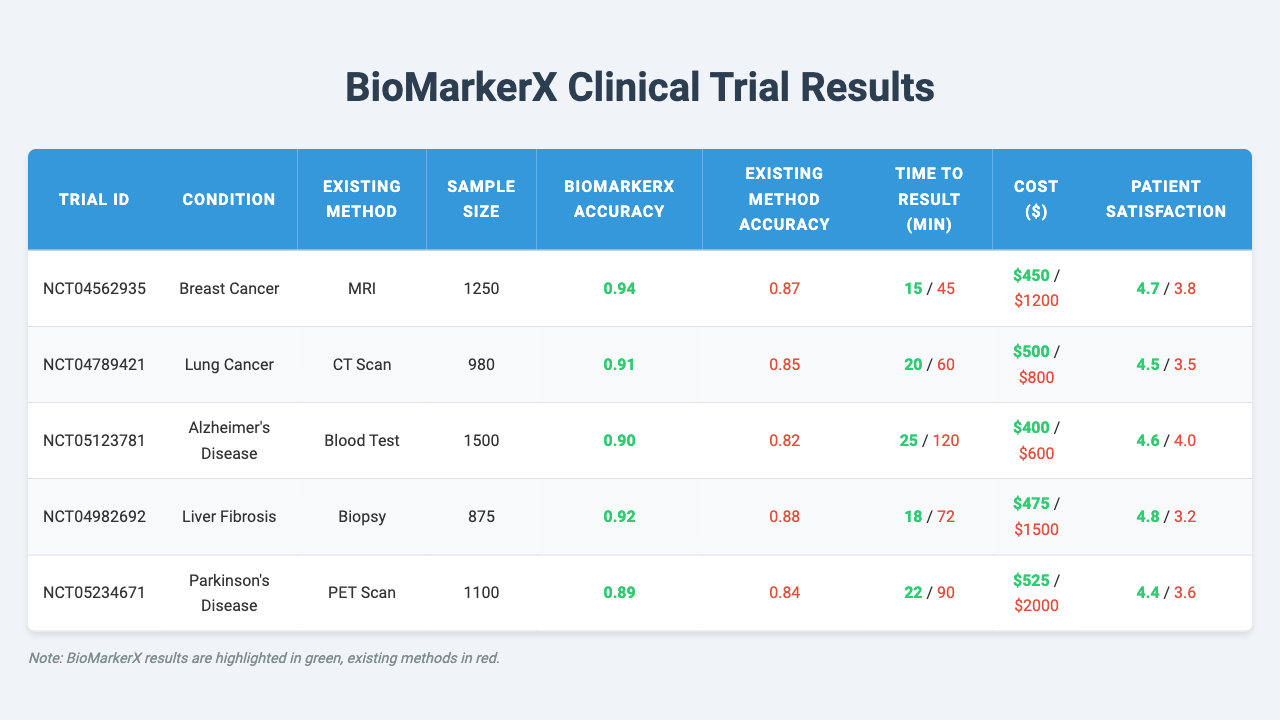What is the highest sensitivity reported for BioMarkerX? From the table, the sensitivity values for BioMarkerX are 0.95, 0.92, 0.89, 0.94, and 0.91. The highest value among these is 0.95.
Answer: 0.95 Which existing method has the highest patient satisfaction rating? The patient satisfaction ratings for existing methods are 3.8, 3.5, 4.0, 3.2, and 3.6. The highest rating is 4.0, corresponding to the Blood Test.
Answer: 4.0 Is the accuracy of BioMarkerX always greater than the accuracy of the existing methods? The accuracy values for BioMarkerX are 0.94, 0.91, 0.90, 0.92, and 0.89, while for existing methods they are 0.87, 0.85, 0.82, 0.88, and 0.84. In each comparison, BioMarkerX shows higher accuracy, so the statement is true.
Answer: Yes What is the average sample size across all trials? The sample sizes for the trials are 1250, 980, 1500, 875, and 1100. Adding these values gives 1250 + 980 + 1500 + 875 + 1100 = 4685. Dividing this sum by 5 results in an average sample size of 4685 / 5 = 937.
Answer: 937 Does BioMarkerX provide results faster than all existing methods listed? Comparing the time to result, BioMarkerX times are 15, 20, 25, 18, and 22 minutes, while the existing methods take 45, 60, 120, 72, and 90 minutes. Since BioMarkerX times are shorter in every case, the answer is true.
Answer: Yes What is the percentage difference in cost between BioMarkerX and the existing methods for Lung Cancer? For Lung Cancer, the cost of BioMarkerX is $500 and the existing method (CT Scan) is $800. To find the percentage difference: (800 - 500) / 800 * 100 = 37.5%.
Answer: 37.5% What is the maximum time to result for the existing methods, and which method does it correspond to? The times to results for existing methods are 45, 60, 120, 72, and 90 minutes. The maximum time is 120 minutes, corresponding to the Blood Test.
Answer: 120 minutes (Blood Test) Which condition has the lowest patient satisfaction rating for BioMarkerX? The patient satisfaction ratings for BioMarkerX are 4.7, 4.5, 4.6, 4.8, and 4.4. The lowest value among these ratings is 4.4, corresponding to Parkinson's Disease.
Answer: 4.4 (Parkinson's Disease) If BioMarkerX's average accuracy and that of the existing methods are compared, what is the difference? The average accuracy of BioMarkerX can be calculated as (0.94 + 0.91 + 0.90 + 0.92 + 0.89) / 5 = 0.93. The average for existing methods is (0.87 + 0.85 + 0.82 + 0.88 + 0.84) / 5 = 0.83. The difference is 0.93 - 0.83 = 0.10.
Answer: 0.10 Which trial had the shortest time to result for any method? The times to result for BioMarkerX are 15, 20, 25, 18, and 22 minutes, while for existing methods, they are 45, 60, 120, 72, and 90 minutes. The shortest time overall is 15 minutes, which corresponds to the trial for Breast Cancer.
Answer: 15 minutes (Breast Cancer) 